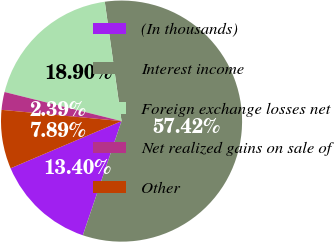Convert chart to OTSL. <chart><loc_0><loc_0><loc_500><loc_500><pie_chart><fcel>(In thousands)<fcel>Interest income<fcel>Foreign exchange losses net<fcel>Net realized gains on sale of<fcel>Other<nl><fcel>13.4%<fcel>57.43%<fcel>18.9%<fcel>2.39%<fcel>7.89%<nl></chart> 